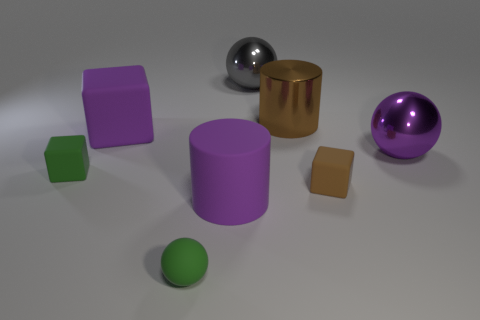Is the matte cylinder the same color as the big cube?
Your answer should be compact. Yes. Do the tiny cube that is to the right of the tiny sphere and the metallic cylinder have the same color?
Your response must be concise. Yes. Is there a large thing of the same color as the large cube?
Provide a succinct answer. Yes. What number of large cylinders are behind the purple cylinder?
Your answer should be compact. 1. What number of other objects are there of the same size as the matte cylinder?
Provide a short and direct response. 4. Do the green object behind the rubber sphere and the sphere that is left of the gray sphere have the same material?
Keep it short and to the point. Yes. What is the color of the matte cylinder that is the same size as the brown metallic object?
Offer a very short reply. Purple. Is there any other thing of the same color as the matte ball?
Ensure brevity in your answer.  Yes. What size is the purple object that is on the right side of the big shiny sphere on the left side of the large purple object that is to the right of the big brown cylinder?
Your answer should be very brief. Large. There is a ball that is left of the shiny cylinder and in front of the brown metal cylinder; what is its color?
Your answer should be compact. Green. 